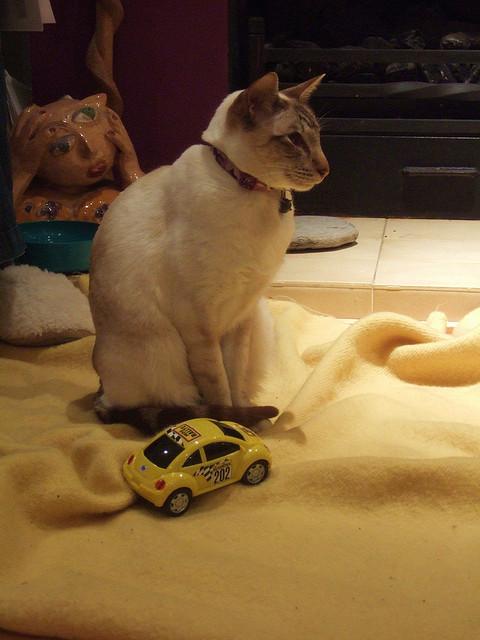What does this animal eat?
Concise answer only. Cat food. Would you expect to find pet hair on this blanket?
Quick response, please. Yes. Is this a normal collar for a cat?
Be succinct. Yes. Is the cat driving the car?
Keep it brief. No. What are the cat's paws on?
Quick response, please. Blanket. What is the animal?
Concise answer only. Cat. Is the animal in the water?
Be succinct. No. What color is the fabric?
Short answer required. Yellow. Does the cat appear to be in danger?
Be succinct. No. Is this a cat?
Concise answer only. Yes. What color is the cat?
Concise answer only. White. Has the little guy had a long day?
Quick response, please. No. Is this cat distracted?
Concise answer only. Yes. Can you recycle what the cat is sitting on?
Write a very short answer. No. What is this cat inside?
Concise answer only. House. What is in the photograph?
Answer briefly. Cat. What type of animal is in this photo?
Give a very brief answer. Cat. Which type of mammal is shown?
Write a very short answer. Cat. What is the cat doing on the rug?
Be succinct. Sitting. Is this a real animal?
Keep it brief. Yes. Are the cats playing with a remote control?
Answer briefly. No. Is this cat stretching?
Write a very short answer. No. What is the cat attacking?
Quick response, please. Nothing. What are the cats doing?
Be succinct. Sitting. What color are the cat's eyes?
Keep it brief. Blue. What is sitting in front of the car?
Short answer required. Cat. Is this a common zoo animal?
Keep it brief. No. What kind of car is that?
Answer briefly. Beetle. Who is this a bust of?
Keep it brief. Cat. What is the cat doing?
Concise answer only. Sitting. Is this a Persian cat?
Answer briefly. Yes. Where was this photo taken?
Write a very short answer. Living room. Is this animal dangerous?
Write a very short answer. No. Where is this cat laying?
Give a very brief answer. Blanket. 